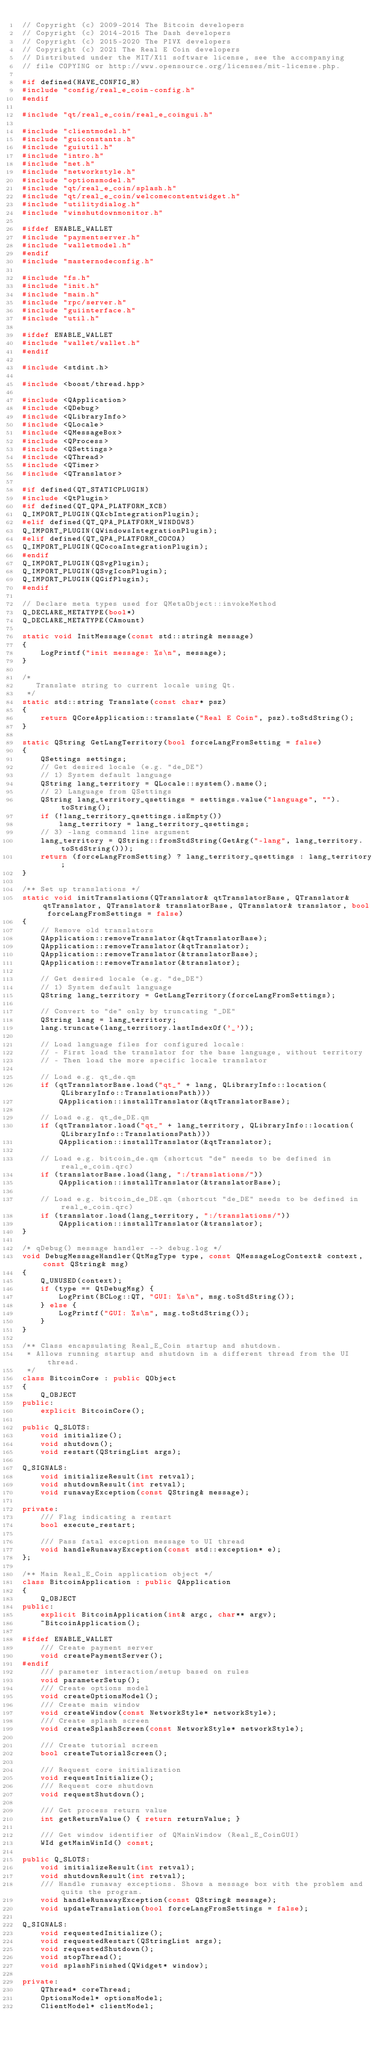<code> <loc_0><loc_0><loc_500><loc_500><_C++_>// Copyright (c) 2009-2014 The Bitcoin developers
// Copyright (c) 2014-2015 The Dash developers
// Copyright (c) 2015-2020 The PIVX developers
// Copyright (c) 2021 The Real E Coin developers
// Distributed under the MIT/X11 software license, see the accompanying
// file COPYING or http://www.opensource.org/licenses/mit-license.php.

#if defined(HAVE_CONFIG_H)
#include "config/real_e_coin-config.h"
#endif

#include "qt/real_e_coin/real_e_coingui.h"

#include "clientmodel.h"
#include "guiconstants.h"
#include "guiutil.h"
#include "intro.h"
#include "net.h"
#include "networkstyle.h"
#include "optionsmodel.h"
#include "qt/real_e_coin/splash.h"
#include "qt/real_e_coin/welcomecontentwidget.h"
#include "utilitydialog.h"
#include "winshutdownmonitor.h"

#ifdef ENABLE_WALLET
#include "paymentserver.h"
#include "walletmodel.h"
#endif
#include "masternodeconfig.h"

#include "fs.h"
#include "init.h"
#include "main.h"
#include "rpc/server.h"
#include "guiinterface.h"
#include "util.h"

#ifdef ENABLE_WALLET
#include "wallet/wallet.h"
#endif

#include <stdint.h>

#include <boost/thread.hpp>

#include <QApplication>
#include <QDebug>
#include <QLibraryInfo>
#include <QLocale>
#include <QMessageBox>
#include <QProcess>
#include <QSettings>
#include <QThread>
#include <QTimer>
#include <QTranslator>

#if defined(QT_STATICPLUGIN)
#include <QtPlugin>
#if defined(QT_QPA_PLATFORM_XCB)
Q_IMPORT_PLUGIN(QXcbIntegrationPlugin);
#elif defined(QT_QPA_PLATFORM_WINDOWS)
Q_IMPORT_PLUGIN(QWindowsIntegrationPlugin);
#elif defined(QT_QPA_PLATFORM_COCOA)
Q_IMPORT_PLUGIN(QCocoaIntegrationPlugin);
#endif
Q_IMPORT_PLUGIN(QSvgPlugin);
Q_IMPORT_PLUGIN(QSvgIconPlugin);
Q_IMPORT_PLUGIN(QGifPlugin);
#endif

// Declare meta types used for QMetaObject::invokeMethod
Q_DECLARE_METATYPE(bool*)
Q_DECLARE_METATYPE(CAmount)

static void InitMessage(const std::string& message)
{
    LogPrintf("init message: %s\n", message);
}

/*
   Translate string to current locale using Qt.
 */
static std::string Translate(const char* psz)
{
    return QCoreApplication::translate("Real E Coin", psz).toStdString();
}

static QString GetLangTerritory(bool forceLangFromSetting = false)
{
    QSettings settings;
    // Get desired locale (e.g. "de_DE")
    // 1) System default language
    QString lang_territory = QLocale::system().name();
    // 2) Language from QSettings
    QString lang_territory_qsettings = settings.value("language", "").toString();
    if (!lang_territory_qsettings.isEmpty())
        lang_territory = lang_territory_qsettings;
    // 3) -lang command line argument
    lang_territory = QString::fromStdString(GetArg("-lang", lang_territory.toStdString()));
    return (forceLangFromSetting) ? lang_territory_qsettings : lang_territory;
}

/** Set up translations */
static void initTranslations(QTranslator& qtTranslatorBase, QTranslator& qtTranslator, QTranslator& translatorBase, QTranslator& translator, bool forceLangFromSettings = false)
{
    // Remove old translators
    QApplication::removeTranslator(&qtTranslatorBase);
    QApplication::removeTranslator(&qtTranslator);
    QApplication::removeTranslator(&translatorBase);
    QApplication::removeTranslator(&translator);

    // Get desired locale (e.g. "de_DE")
    // 1) System default language
    QString lang_territory = GetLangTerritory(forceLangFromSettings);

    // Convert to "de" only by truncating "_DE"
    QString lang = lang_territory;
    lang.truncate(lang_territory.lastIndexOf('_'));

    // Load language files for configured locale:
    // - First load the translator for the base language, without territory
    // - Then load the more specific locale translator

    // Load e.g. qt_de.qm
    if (qtTranslatorBase.load("qt_" + lang, QLibraryInfo::location(QLibraryInfo::TranslationsPath)))
        QApplication::installTranslator(&qtTranslatorBase);

    // Load e.g. qt_de_DE.qm
    if (qtTranslator.load("qt_" + lang_territory, QLibraryInfo::location(QLibraryInfo::TranslationsPath)))
        QApplication::installTranslator(&qtTranslator);

    // Load e.g. bitcoin_de.qm (shortcut "de" needs to be defined in real_e_coin.qrc)
    if (translatorBase.load(lang, ":/translations/"))
        QApplication::installTranslator(&translatorBase);

    // Load e.g. bitcoin_de_DE.qm (shortcut "de_DE" needs to be defined in real_e_coin.qrc)
    if (translator.load(lang_territory, ":/translations/"))
        QApplication::installTranslator(&translator);
}

/* qDebug() message handler --> debug.log */
void DebugMessageHandler(QtMsgType type, const QMessageLogContext& context, const QString& msg)
{
    Q_UNUSED(context);
    if (type == QtDebugMsg) {
        LogPrint(BCLog::QT, "GUI: %s\n", msg.toStdString());
    } else {
        LogPrintf("GUI: %s\n", msg.toStdString());
    }
}

/** Class encapsulating Real_E_Coin startup and shutdown.
 * Allows running startup and shutdown in a different thread from the UI thread.
 */
class BitcoinCore : public QObject
{
    Q_OBJECT
public:
    explicit BitcoinCore();

public Q_SLOTS:
    void initialize();
    void shutdown();
    void restart(QStringList args);

Q_SIGNALS:
    void initializeResult(int retval);
    void shutdownResult(int retval);
    void runawayException(const QString& message);

private:
    /// Flag indicating a restart
    bool execute_restart;

    /// Pass fatal exception message to UI thread
    void handleRunawayException(const std::exception* e);
};

/** Main Real_E_Coin application object */
class BitcoinApplication : public QApplication
{
    Q_OBJECT
public:
    explicit BitcoinApplication(int& argc, char** argv);
    ~BitcoinApplication();

#ifdef ENABLE_WALLET
    /// Create payment server
    void createPaymentServer();
#endif
    /// parameter interaction/setup based on rules
    void parameterSetup();
    /// Create options model
    void createOptionsModel();
    /// Create main window
    void createWindow(const NetworkStyle* networkStyle);
    /// Create splash screen
    void createSplashScreen(const NetworkStyle* networkStyle);

    /// Create tutorial screen
    bool createTutorialScreen();

    /// Request core initialization
    void requestInitialize();
    /// Request core shutdown
    void requestShutdown();

    /// Get process return value
    int getReturnValue() { return returnValue; }

    /// Get window identifier of QMainWindow (Real_E_CoinGUI)
    WId getMainWinId() const;

public Q_SLOTS:
    void initializeResult(int retval);
    void shutdownResult(int retval);
    /// Handle runaway exceptions. Shows a message box with the problem and quits the program.
    void handleRunawayException(const QString& message);
    void updateTranslation(bool forceLangFromSettings = false);

Q_SIGNALS:
    void requestedInitialize();
    void requestedRestart(QStringList args);
    void requestedShutdown();
    void stopThread();
    void splashFinished(QWidget* window);

private:
    QThread* coreThread;
    OptionsModel* optionsModel;
    ClientModel* clientModel;</code> 